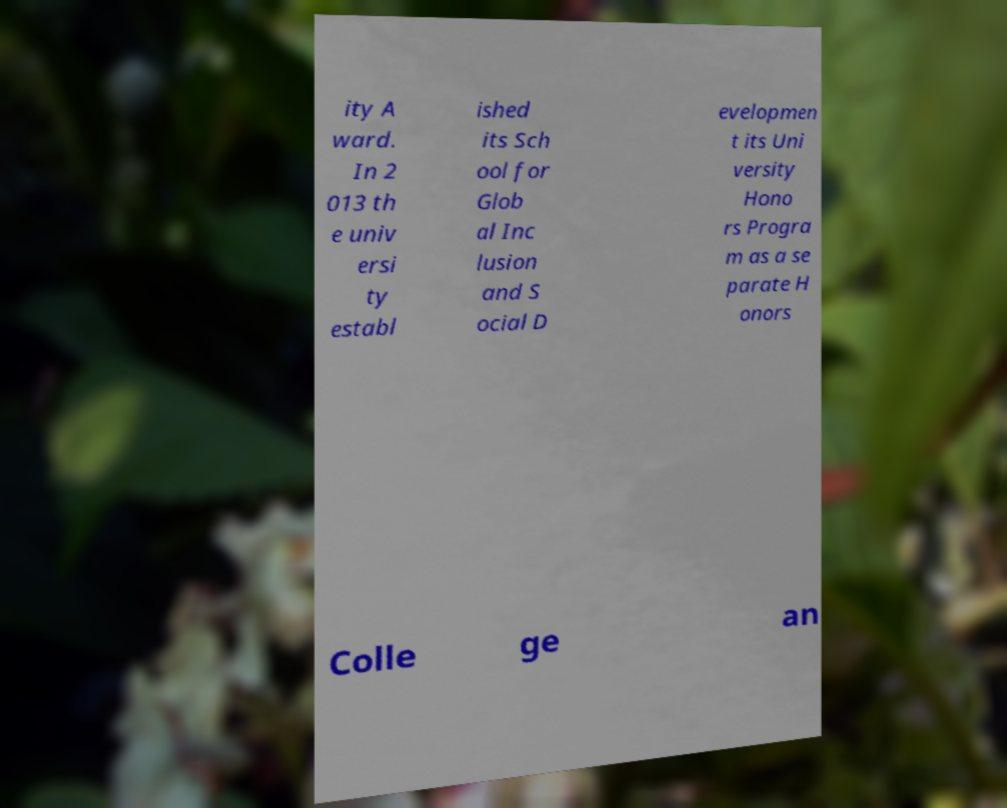What messages or text are displayed in this image? I need them in a readable, typed format. ity A ward. In 2 013 th e univ ersi ty establ ished its Sch ool for Glob al Inc lusion and S ocial D evelopmen t its Uni versity Hono rs Progra m as a se parate H onors Colle ge an 